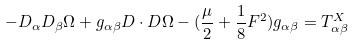<formula> <loc_0><loc_0><loc_500><loc_500>- D _ { \alpha } D _ { \beta } \Omega + g _ { \alpha \beta } D \cdot D \Omega - ( \frac { \mu } { 2 } + \frac { 1 } { 8 } F ^ { 2 } ) g _ { \alpha \beta } = T ^ { X } _ { \alpha \beta }</formula> 